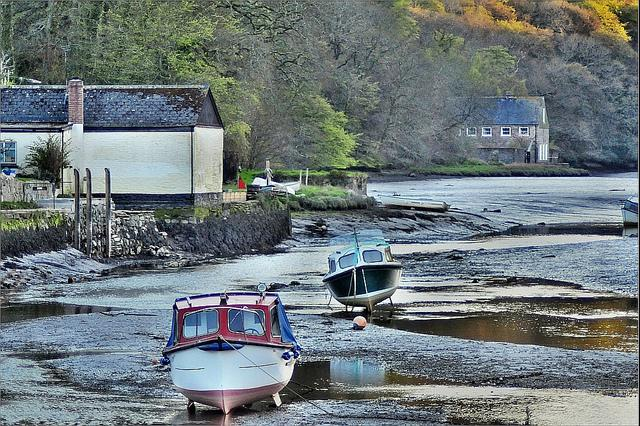What shape is the item on the floor that is in front of the boat that is behind the red boat?

Choices:
A) square
B) rectangle
C) rhombus
D) round round 